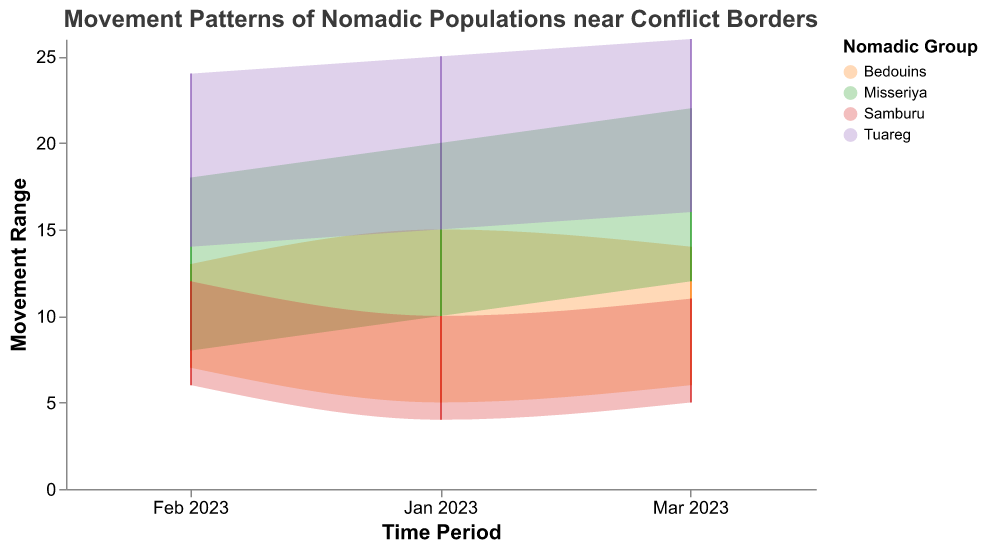What's the title of the figure? The title of the figure is usually placed at the top and summarizes the main topic of the visualized data. The title here is "Movement Patterns of Nomadic Populations near Conflict Borders."
Answer: Movement Patterns of Nomadic Populations near Conflict Borders Which nomadic group is represented by the color #ff7f0e? By looking at the color legend of the chart, we can see that the Bedouins are represented by the color #ff7f0e.
Answer: Bedouins How many time periods are displayed for each nomadic group? From the x-axis, we observe three distinct time periods: January 2023, February 2023, and March 2023, making it three time periods for each nomadic group.
Answer: 3 What's the maximum observed movement for the Tuareg group? To find this, we look at the y-axis values for the Tuareg group and identify the highest point, which is in March 2023 at a point of 26.
Answer: 26 What is a unique characteristic of the range area chart compared to other charts? A unique characteristic of the range area chart is that it displays both the minimum and maximum values for each data point, illustrating the spread or range within which the data varies.
Answer: Displays both min and max values Which nomadic group had the lowest movement range in January 2023? Examine the data points for January 2023 across the groups. The Samburu group had a range between 4 and 10, the smallest among the groups.
Answer: Samburu Compare the movement range of the Misseriya group between February and March 2023. What do you observe? In February 2023, the Misseriya group had a range of 8 to 18, while in March 2023, it was 12 to 22. The range increased from 10 units in February to 10 units in March, and both minimum and maximum values increased.
Answer: The range remained 10 units, min and max values increased What is the average minimum movement of the Bedouins across the three time periods? Sum the minimum movements for January, February, and March (5 + 7 + 6 = 18) and divide by 3. The average minimum movement is 18 / 3 = 6.
Answer: 6 Which group experienced the greatest increase in their maximum movement from January to March 2023? Calculate the difference in maximum movements from January to March for each group. The Tuareg had an increase of 26 - 25 = 1, the Misseriya had 22 - 20 = 2, the Samburu had 11 - 10 = 1, and the Bedouins had 14 - 15 = -1 (a decrease). The Misseriya experienced the greatest increase.
Answer: Misseriya What is the trend in the minimum movement of the Tuareg group over the shown time periods? Examining the minimum movement values for the Tuareg across January, February, and March, we see an increase from 15 to 14 to 16, indicating a decreasing then increasing trend.
Answer: Decreasing then increasing trend 